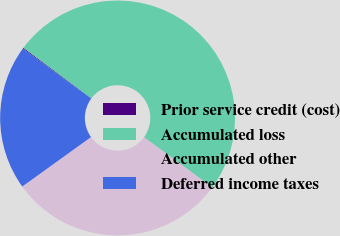<chart> <loc_0><loc_0><loc_500><loc_500><pie_chart><fcel>Prior service credit (cost)<fcel>Accumulated loss<fcel>Accumulated other<fcel>Deferred income taxes<nl><fcel>0.12%<fcel>49.88%<fcel>30.0%<fcel>20.0%<nl></chart> 